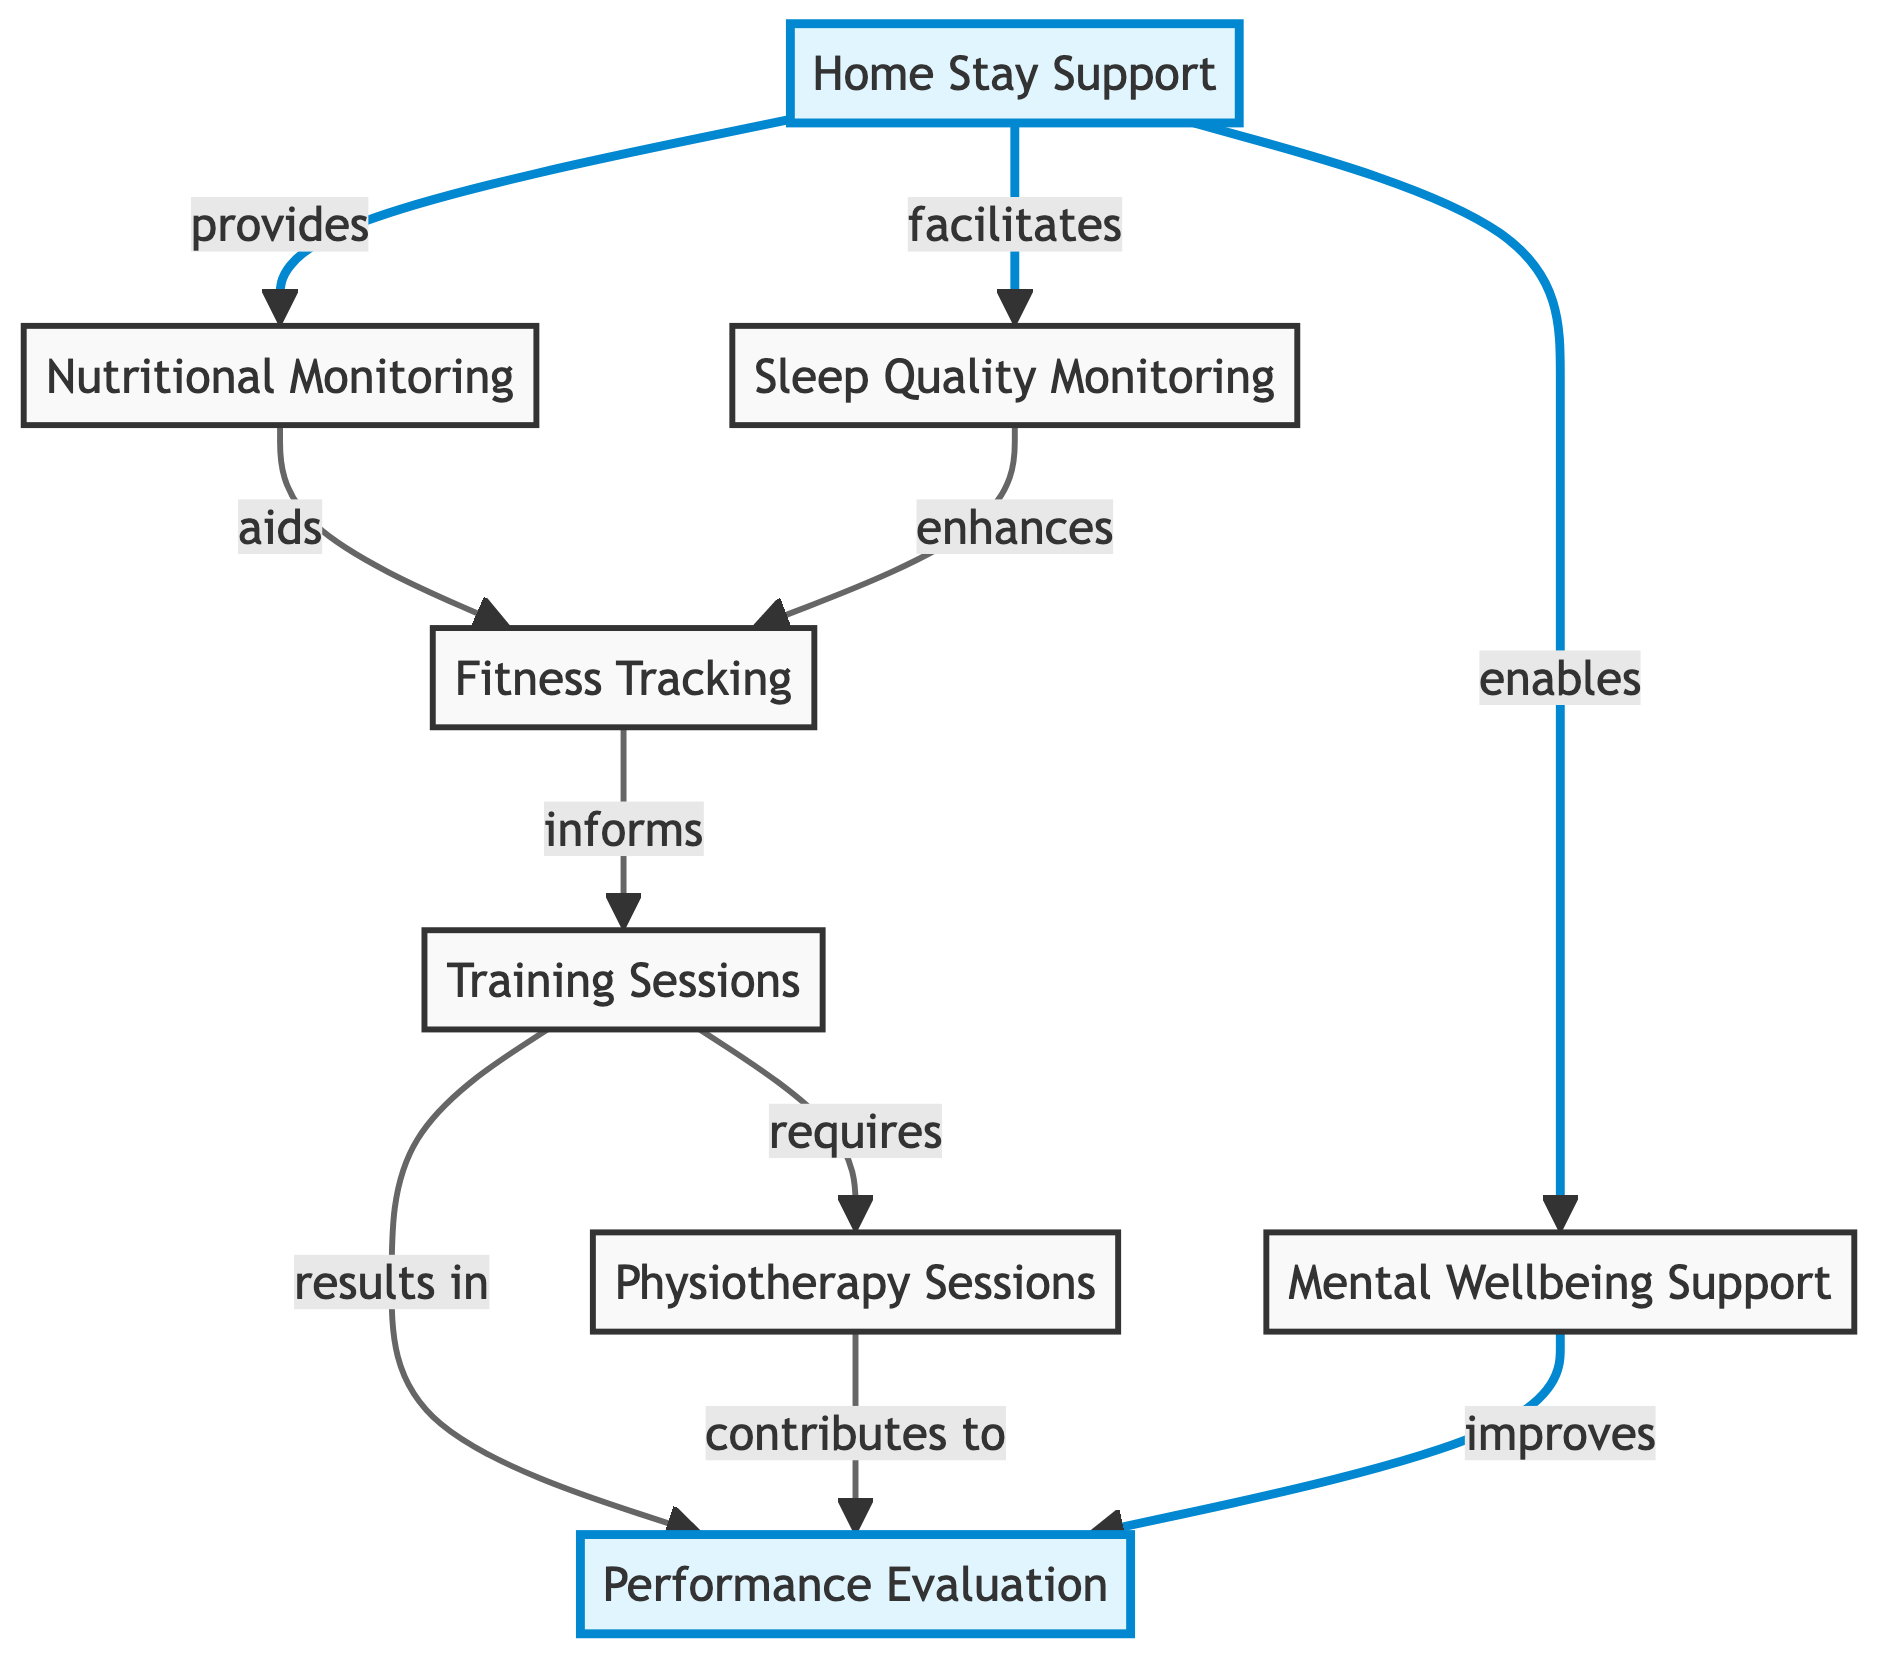What is the total number of nodes in the diagram? Counting the nodes listed in the diagram, we find eight distinct nodes: Home Stay Support, Nutritional Monitoring, Fitness Tracking, Mental Wellbeing Support, Training Sessions, Physiotherapy Sessions, Sleep Quality Monitoring, and Performance Evaluation.
Answer: 8 Which node does "Home Stay Support" provide to? The diagram shows that "Home Stay Support" provides to "Nutritional Monitoring," as indicated by the directed edge labeled "provides."
Answer: Nutritional Monitoring What relationship exists between "Training Sessions" and "Performance Evaluation"? "Training Sessions" results in "Performance Evaluation," as shown by the directed edge labeled "results in." This indicates that the training sessions lead directly to evaluating performance.
Answer: results in How many direct influences does "Home Stay Support" have? Looking at the edges from "Home Stay Support," it has three direct influences: "Nutritional Monitoring," "Mental Wellbeing Support," and "Sleep Quality Monitoring."
Answer: 3 What effect does "Sleep Quality Monitoring" have on "Fitness Tracking"? The edge labeled "enhances" indicates that "Sleep Quality Monitoring" enhances the effectiveness of "Fitness Tracking."
Answer: enhances Which node requires "Physiotherapy Sessions"? The directed edge from "Training Sessions" to "Physiotherapy Sessions" indicates that "Training Sessions" requires "Physiotherapy Sessions" for its effectiveness.
Answer: Training Sessions What contributes to "Performance Evaluation"? Two nodes contribute to "Performance Evaluation": "Training Sessions," which results in it, and "Physiotherapy Sessions," which also contributes to it, as shown by the directed edges leading to "Performance Evaluation."
Answer: Training Sessions, Physiotherapy Sessions How does "Nutritional Monitoring" aid the training process? "Nutritional Monitoring" aids "Fitness Tracking," which is crucial for the training process as it informs "Training Sessions." Therefore, it plays a significant role in enhancing training effectiveness.
Answer: aids What improves the "Performance Evaluation"? The "Mental Wellbeing Support" directly impacts "Performance Evaluation" by improving it, as indicated by the directed edge labeled "improves."
Answer: improves 